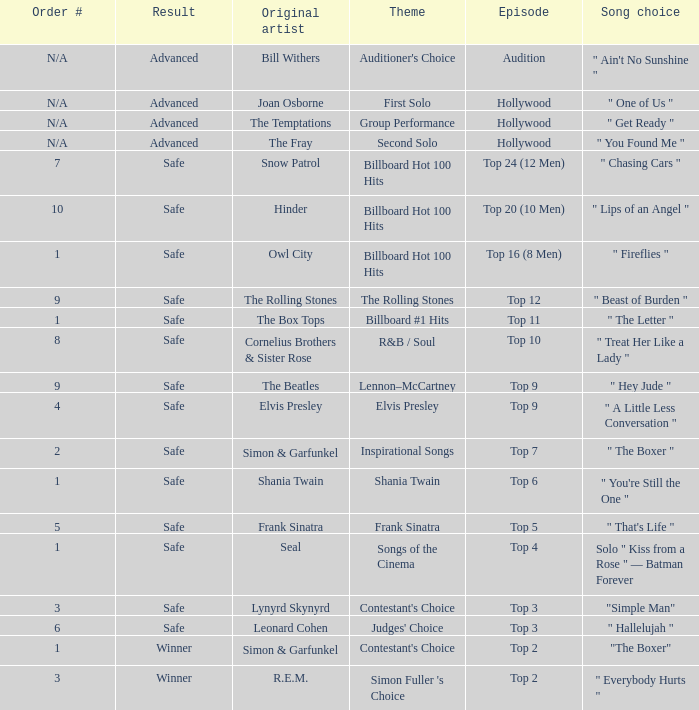The theme Auditioner's Choice	has what song choice? " Ain't No Sunshine ". 